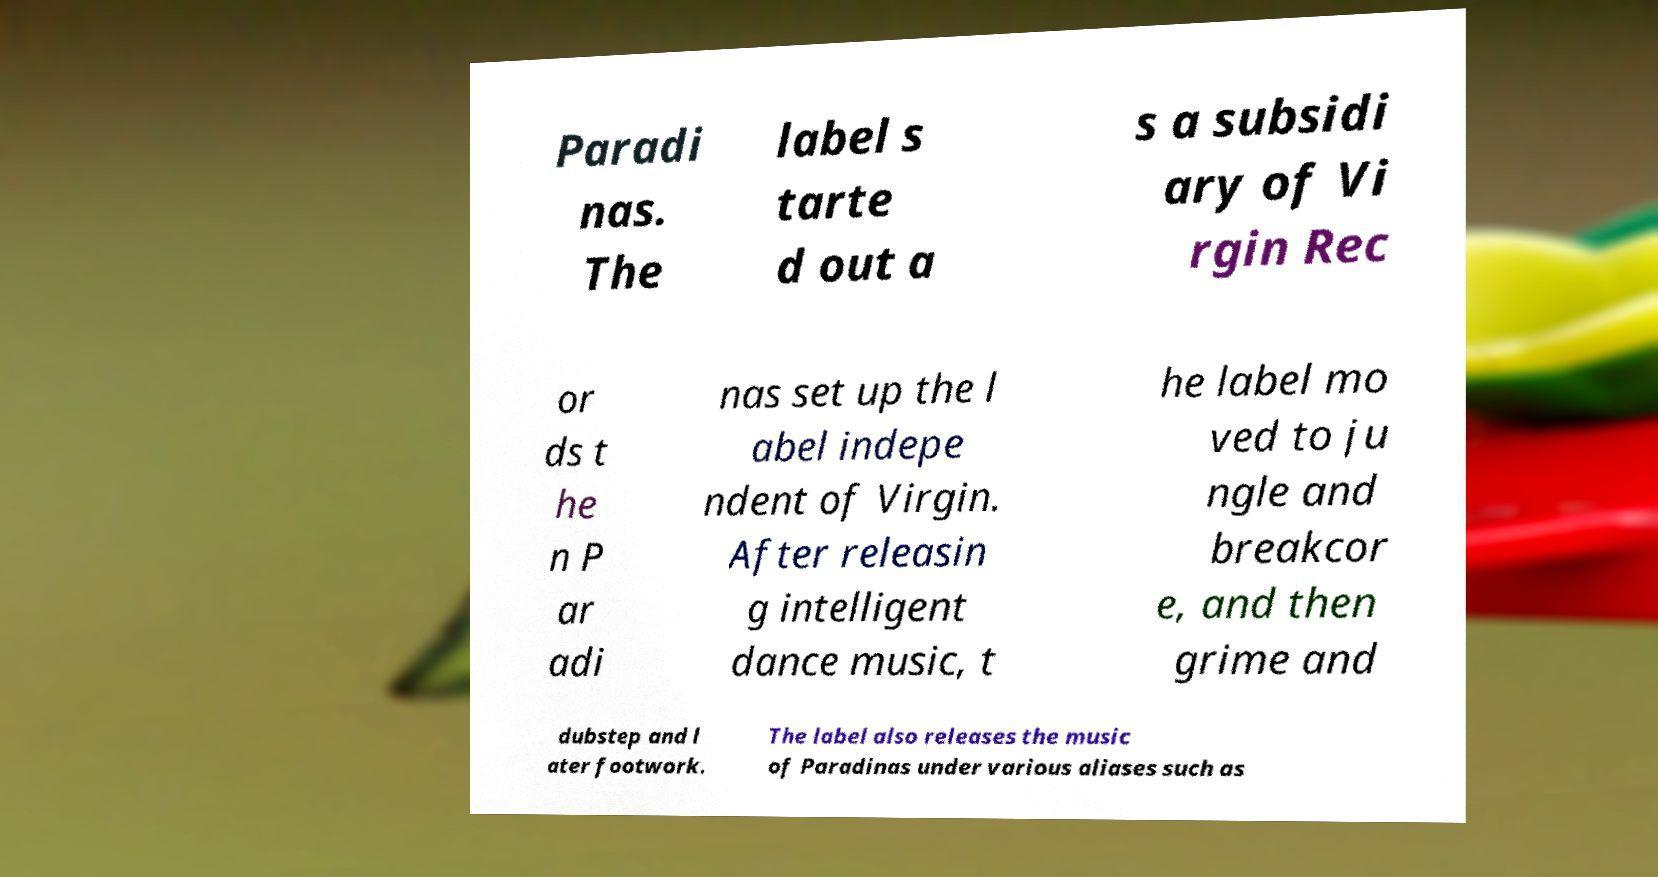For documentation purposes, I need the text within this image transcribed. Could you provide that? Paradi nas. The label s tarte d out a s a subsidi ary of Vi rgin Rec or ds t he n P ar adi nas set up the l abel indepe ndent of Virgin. After releasin g intelligent dance music, t he label mo ved to ju ngle and breakcor e, and then grime and dubstep and l ater footwork. The label also releases the music of Paradinas under various aliases such as 